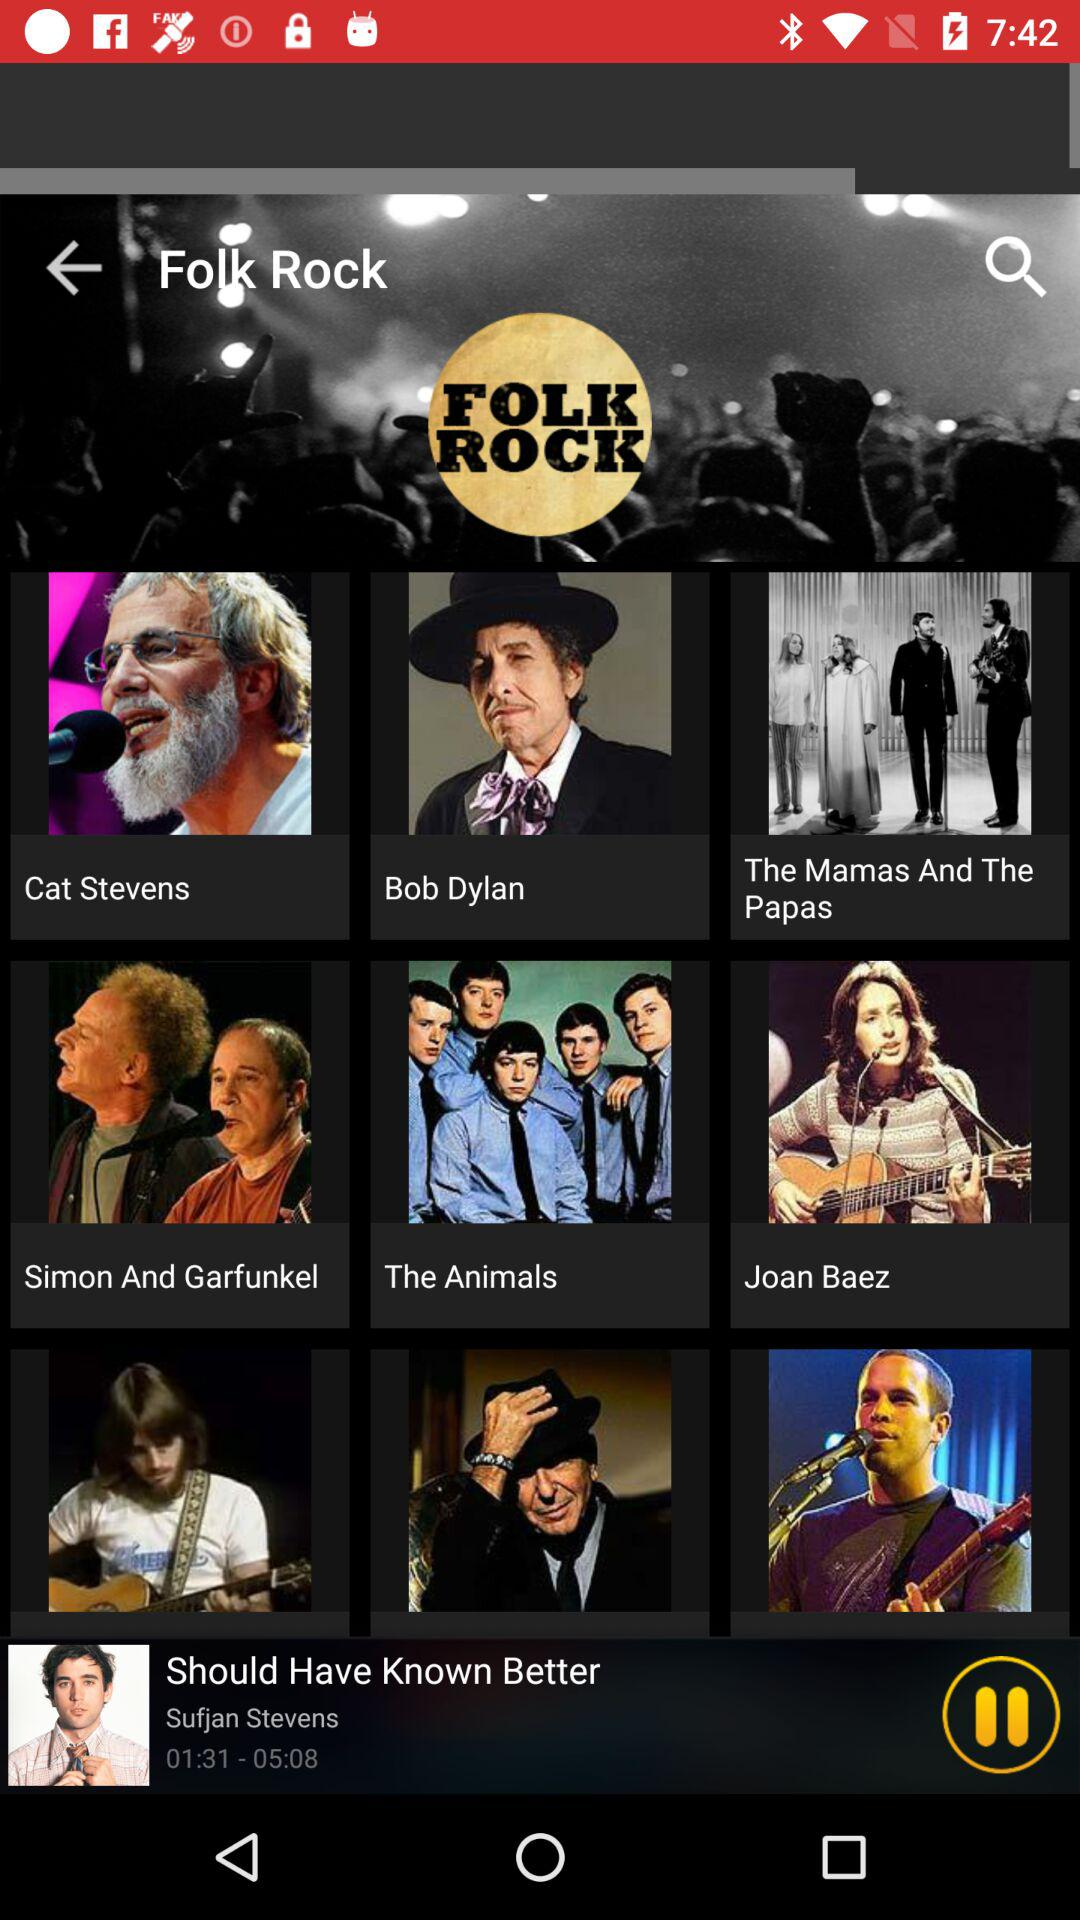What is the name of the currently playing song? The name of the currently playing song is "Should Have Known Better". 